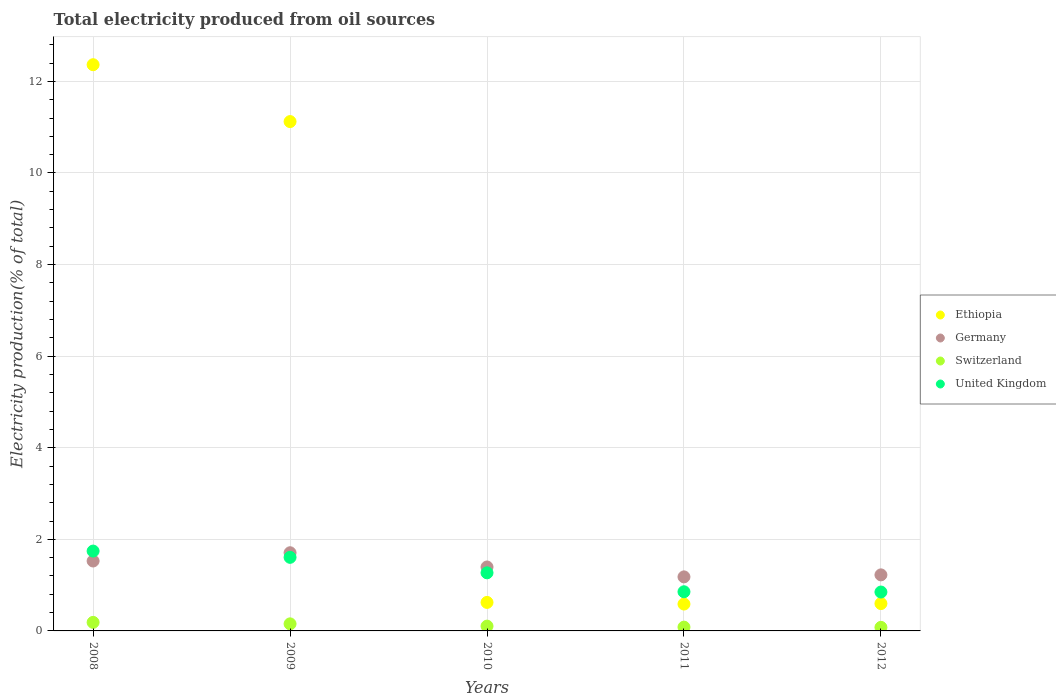Is the number of dotlines equal to the number of legend labels?
Your answer should be compact. Yes. What is the total electricity produced in United Kingdom in 2011?
Give a very brief answer. 0.86. Across all years, what is the maximum total electricity produced in Switzerland?
Your answer should be very brief. 0.19. Across all years, what is the minimum total electricity produced in United Kingdom?
Provide a succinct answer. 0.85. What is the total total electricity produced in Switzerland in the graph?
Make the answer very short. 0.61. What is the difference between the total electricity produced in Germany in 2009 and that in 2011?
Provide a succinct answer. 0.53. What is the difference between the total electricity produced in United Kingdom in 2011 and the total electricity produced in Ethiopia in 2010?
Provide a short and direct response. 0.23. What is the average total electricity produced in United Kingdom per year?
Keep it short and to the point. 1.26. In the year 2009, what is the difference between the total electricity produced in Germany and total electricity produced in Ethiopia?
Provide a short and direct response. -9.41. In how many years, is the total electricity produced in Switzerland greater than 11.2 %?
Provide a succinct answer. 0. What is the ratio of the total electricity produced in United Kingdom in 2009 to that in 2011?
Provide a short and direct response. 1.88. What is the difference between the highest and the second highest total electricity produced in Germany?
Ensure brevity in your answer.  0.18. What is the difference between the highest and the lowest total electricity produced in Ethiopia?
Your answer should be compact. 11.78. In how many years, is the total electricity produced in Ethiopia greater than the average total electricity produced in Ethiopia taken over all years?
Your response must be concise. 2. Is the sum of the total electricity produced in United Kingdom in 2008 and 2010 greater than the maximum total electricity produced in Switzerland across all years?
Ensure brevity in your answer.  Yes. Is it the case that in every year, the sum of the total electricity produced in Germany and total electricity produced in Ethiopia  is greater than the sum of total electricity produced in Switzerland and total electricity produced in United Kingdom?
Provide a short and direct response. No. Does the total electricity produced in Germany monotonically increase over the years?
Your answer should be compact. No. Is the total electricity produced in Germany strictly greater than the total electricity produced in Switzerland over the years?
Provide a succinct answer. Yes. Is the total electricity produced in Germany strictly less than the total electricity produced in Switzerland over the years?
Your answer should be compact. No. How many dotlines are there?
Provide a short and direct response. 4. What is the difference between two consecutive major ticks on the Y-axis?
Offer a terse response. 2. Are the values on the major ticks of Y-axis written in scientific E-notation?
Provide a short and direct response. No. Does the graph contain grids?
Provide a short and direct response. Yes. How many legend labels are there?
Offer a very short reply. 4. How are the legend labels stacked?
Provide a succinct answer. Vertical. What is the title of the graph?
Offer a very short reply. Total electricity produced from oil sources. What is the label or title of the X-axis?
Your response must be concise. Years. What is the label or title of the Y-axis?
Your response must be concise. Electricity production(% of total). What is the Electricity production(% of total) of Ethiopia in 2008?
Make the answer very short. 12.36. What is the Electricity production(% of total) in Germany in 2008?
Offer a terse response. 1.53. What is the Electricity production(% of total) in Switzerland in 2008?
Keep it short and to the point. 0.19. What is the Electricity production(% of total) in United Kingdom in 2008?
Give a very brief answer. 1.74. What is the Electricity production(% of total) in Ethiopia in 2009?
Ensure brevity in your answer.  11.12. What is the Electricity production(% of total) of Germany in 2009?
Provide a succinct answer. 1.71. What is the Electricity production(% of total) in Switzerland in 2009?
Ensure brevity in your answer.  0.15. What is the Electricity production(% of total) of United Kingdom in 2009?
Ensure brevity in your answer.  1.61. What is the Electricity production(% of total) in Ethiopia in 2010?
Keep it short and to the point. 0.62. What is the Electricity production(% of total) of Germany in 2010?
Offer a terse response. 1.4. What is the Electricity production(% of total) of Switzerland in 2010?
Make the answer very short. 0.1. What is the Electricity production(% of total) in United Kingdom in 2010?
Offer a very short reply. 1.27. What is the Electricity production(% of total) in Ethiopia in 2011?
Ensure brevity in your answer.  0.59. What is the Electricity production(% of total) of Germany in 2011?
Your response must be concise. 1.18. What is the Electricity production(% of total) of Switzerland in 2011?
Ensure brevity in your answer.  0.08. What is the Electricity production(% of total) in United Kingdom in 2011?
Make the answer very short. 0.86. What is the Electricity production(% of total) in Ethiopia in 2012?
Give a very brief answer. 0.6. What is the Electricity production(% of total) in Germany in 2012?
Provide a short and direct response. 1.22. What is the Electricity production(% of total) of Switzerland in 2012?
Ensure brevity in your answer.  0.08. What is the Electricity production(% of total) in United Kingdom in 2012?
Offer a very short reply. 0.85. Across all years, what is the maximum Electricity production(% of total) of Ethiopia?
Keep it short and to the point. 12.36. Across all years, what is the maximum Electricity production(% of total) in Germany?
Give a very brief answer. 1.71. Across all years, what is the maximum Electricity production(% of total) in Switzerland?
Your answer should be very brief. 0.19. Across all years, what is the maximum Electricity production(% of total) of United Kingdom?
Give a very brief answer. 1.74. Across all years, what is the minimum Electricity production(% of total) of Ethiopia?
Provide a succinct answer. 0.59. Across all years, what is the minimum Electricity production(% of total) in Germany?
Offer a terse response. 1.18. Across all years, what is the minimum Electricity production(% of total) in Switzerland?
Keep it short and to the point. 0.08. Across all years, what is the minimum Electricity production(% of total) in United Kingdom?
Provide a short and direct response. 0.85. What is the total Electricity production(% of total) in Ethiopia in the graph?
Give a very brief answer. 25.29. What is the total Electricity production(% of total) in Germany in the graph?
Keep it short and to the point. 7.03. What is the total Electricity production(% of total) in Switzerland in the graph?
Your answer should be compact. 0.61. What is the total Electricity production(% of total) of United Kingdom in the graph?
Provide a succinct answer. 6.32. What is the difference between the Electricity production(% of total) of Ethiopia in 2008 and that in 2009?
Offer a terse response. 1.24. What is the difference between the Electricity production(% of total) in Germany in 2008 and that in 2009?
Your response must be concise. -0.18. What is the difference between the Electricity production(% of total) in Switzerland in 2008 and that in 2009?
Give a very brief answer. 0.03. What is the difference between the Electricity production(% of total) in United Kingdom in 2008 and that in 2009?
Give a very brief answer. 0.14. What is the difference between the Electricity production(% of total) of Ethiopia in 2008 and that in 2010?
Your answer should be compact. 11.74. What is the difference between the Electricity production(% of total) in Germany in 2008 and that in 2010?
Give a very brief answer. 0.13. What is the difference between the Electricity production(% of total) in Switzerland in 2008 and that in 2010?
Give a very brief answer. 0.08. What is the difference between the Electricity production(% of total) in United Kingdom in 2008 and that in 2010?
Offer a terse response. 0.47. What is the difference between the Electricity production(% of total) of Ethiopia in 2008 and that in 2011?
Give a very brief answer. 11.78. What is the difference between the Electricity production(% of total) of Germany in 2008 and that in 2011?
Your response must be concise. 0.35. What is the difference between the Electricity production(% of total) in Switzerland in 2008 and that in 2011?
Give a very brief answer. 0.1. What is the difference between the Electricity production(% of total) of United Kingdom in 2008 and that in 2011?
Give a very brief answer. 0.89. What is the difference between the Electricity production(% of total) in Ethiopia in 2008 and that in 2012?
Your answer should be very brief. 11.77. What is the difference between the Electricity production(% of total) in Germany in 2008 and that in 2012?
Provide a short and direct response. 0.3. What is the difference between the Electricity production(% of total) of Switzerland in 2008 and that in 2012?
Keep it short and to the point. 0.11. What is the difference between the Electricity production(% of total) in United Kingdom in 2008 and that in 2012?
Provide a short and direct response. 0.89. What is the difference between the Electricity production(% of total) in Ethiopia in 2009 and that in 2010?
Your response must be concise. 10.5. What is the difference between the Electricity production(% of total) in Germany in 2009 and that in 2010?
Provide a succinct answer. 0.31. What is the difference between the Electricity production(% of total) in United Kingdom in 2009 and that in 2010?
Your response must be concise. 0.34. What is the difference between the Electricity production(% of total) in Ethiopia in 2009 and that in 2011?
Provide a short and direct response. 10.54. What is the difference between the Electricity production(% of total) of Germany in 2009 and that in 2011?
Offer a very short reply. 0.53. What is the difference between the Electricity production(% of total) of Switzerland in 2009 and that in 2011?
Offer a terse response. 0.07. What is the difference between the Electricity production(% of total) in United Kingdom in 2009 and that in 2011?
Make the answer very short. 0.75. What is the difference between the Electricity production(% of total) of Ethiopia in 2009 and that in 2012?
Offer a very short reply. 10.53. What is the difference between the Electricity production(% of total) in Germany in 2009 and that in 2012?
Provide a succinct answer. 0.48. What is the difference between the Electricity production(% of total) of Switzerland in 2009 and that in 2012?
Your answer should be compact. 0.08. What is the difference between the Electricity production(% of total) of United Kingdom in 2009 and that in 2012?
Give a very brief answer. 0.76. What is the difference between the Electricity production(% of total) in Ethiopia in 2010 and that in 2011?
Make the answer very short. 0.04. What is the difference between the Electricity production(% of total) of Germany in 2010 and that in 2011?
Ensure brevity in your answer.  0.22. What is the difference between the Electricity production(% of total) of Switzerland in 2010 and that in 2011?
Give a very brief answer. 0.02. What is the difference between the Electricity production(% of total) in United Kingdom in 2010 and that in 2011?
Make the answer very short. 0.41. What is the difference between the Electricity production(% of total) of Ethiopia in 2010 and that in 2012?
Make the answer very short. 0.03. What is the difference between the Electricity production(% of total) of Germany in 2010 and that in 2012?
Provide a short and direct response. 0.17. What is the difference between the Electricity production(% of total) in Switzerland in 2010 and that in 2012?
Give a very brief answer. 0.03. What is the difference between the Electricity production(% of total) in United Kingdom in 2010 and that in 2012?
Provide a short and direct response. 0.42. What is the difference between the Electricity production(% of total) in Ethiopia in 2011 and that in 2012?
Offer a very short reply. -0.01. What is the difference between the Electricity production(% of total) of Germany in 2011 and that in 2012?
Give a very brief answer. -0.04. What is the difference between the Electricity production(% of total) of Switzerland in 2011 and that in 2012?
Offer a very short reply. 0. What is the difference between the Electricity production(% of total) of United Kingdom in 2011 and that in 2012?
Keep it short and to the point. 0.01. What is the difference between the Electricity production(% of total) in Ethiopia in 2008 and the Electricity production(% of total) in Germany in 2009?
Keep it short and to the point. 10.66. What is the difference between the Electricity production(% of total) of Ethiopia in 2008 and the Electricity production(% of total) of Switzerland in 2009?
Your answer should be compact. 12.21. What is the difference between the Electricity production(% of total) in Ethiopia in 2008 and the Electricity production(% of total) in United Kingdom in 2009?
Give a very brief answer. 10.76. What is the difference between the Electricity production(% of total) in Germany in 2008 and the Electricity production(% of total) in Switzerland in 2009?
Provide a short and direct response. 1.37. What is the difference between the Electricity production(% of total) in Germany in 2008 and the Electricity production(% of total) in United Kingdom in 2009?
Provide a succinct answer. -0.08. What is the difference between the Electricity production(% of total) in Switzerland in 2008 and the Electricity production(% of total) in United Kingdom in 2009?
Ensure brevity in your answer.  -1.42. What is the difference between the Electricity production(% of total) of Ethiopia in 2008 and the Electricity production(% of total) of Germany in 2010?
Provide a succinct answer. 10.97. What is the difference between the Electricity production(% of total) in Ethiopia in 2008 and the Electricity production(% of total) in Switzerland in 2010?
Give a very brief answer. 12.26. What is the difference between the Electricity production(% of total) of Ethiopia in 2008 and the Electricity production(% of total) of United Kingdom in 2010?
Provide a short and direct response. 11.1. What is the difference between the Electricity production(% of total) in Germany in 2008 and the Electricity production(% of total) in Switzerland in 2010?
Keep it short and to the point. 1.42. What is the difference between the Electricity production(% of total) in Germany in 2008 and the Electricity production(% of total) in United Kingdom in 2010?
Your answer should be compact. 0.26. What is the difference between the Electricity production(% of total) of Switzerland in 2008 and the Electricity production(% of total) of United Kingdom in 2010?
Make the answer very short. -1.08. What is the difference between the Electricity production(% of total) in Ethiopia in 2008 and the Electricity production(% of total) in Germany in 2011?
Provide a succinct answer. 11.18. What is the difference between the Electricity production(% of total) in Ethiopia in 2008 and the Electricity production(% of total) in Switzerland in 2011?
Offer a terse response. 12.28. What is the difference between the Electricity production(% of total) of Ethiopia in 2008 and the Electricity production(% of total) of United Kingdom in 2011?
Your response must be concise. 11.51. What is the difference between the Electricity production(% of total) of Germany in 2008 and the Electricity production(% of total) of Switzerland in 2011?
Your response must be concise. 1.44. What is the difference between the Electricity production(% of total) in Germany in 2008 and the Electricity production(% of total) in United Kingdom in 2011?
Make the answer very short. 0.67. What is the difference between the Electricity production(% of total) in Switzerland in 2008 and the Electricity production(% of total) in United Kingdom in 2011?
Provide a succinct answer. -0.67. What is the difference between the Electricity production(% of total) in Ethiopia in 2008 and the Electricity production(% of total) in Germany in 2012?
Provide a succinct answer. 11.14. What is the difference between the Electricity production(% of total) in Ethiopia in 2008 and the Electricity production(% of total) in Switzerland in 2012?
Provide a succinct answer. 12.29. What is the difference between the Electricity production(% of total) in Ethiopia in 2008 and the Electricity production(% of total) in United Kingdom in 2012?
Ensure brevity in your answer.  11.52. What is the difference between the Electricity production(% of total) in Germany in 2008 and the Electricity production(% of total) in Switzerland in 2012?
Your answer should be very brief. 1.45. What is the difference between the Electricity production(% of total) in Germany in 2008 and the Electricity production(% of total) in United Kingdom in 2012?
Keep it short and to the point. 0.68. What is the difference between the Electricity production(% of total) in Switzerland in 2008 and the Electricity production(% of total) in United Kingdom in 2012?
Your response must be concise. -0.66. What is the difference between the Electricity production(% of total) of Ethiopia in 2009 and the Electricity production(% of total) of Germany in 2010?
Your response must be concise. 9.73. What is the difference between the Electricity production(% of total) in Ethiopia in 2009 and the Electricity production(% of total) in Switzerland in 2010?
Make the answer very short. 11.02. What is the difference between the Electricity production(% of total) in Ethiopia in 2009 and the Electricity production(% of total) in United Kingdom in 2010?
Make the answer very short. 9.85. What is the difference between the Electricity production(% of total) of Germany in 2009 and the Electricity production(% of total) of Switzerland in 2010?
Ensure brevity in your answer.  1.6. What is the difference between the Electricity production(% of total) in Germany in 2009 and the Electricity production(% of total) in United Kingdom in 2010?
Offer a very short reply. 0.44. What is the difference between the Electricity production(% of total) of Switzerland in 2009 and the Electricity production(% of total) of United Kingdom in 2010?
Ensure brevity in your answer.  -1.11. What is the difference between the Electricity production(% of total) of Ethiopia in 2009 and the Electricity production(% of total) of Germany in 2011?
Give a very brief answer. 9.94. What is the difference between the Electricity production(% of total) of Ethiopia in 2009 and the Electricity production(% of total) of Switzerland in 2011?
Your response must be concise. 11.04. What is the difference between the Electricity production(% of total) of Ethiopia in 2009 and the Electricity production(% of total) of United Kingdom in 2011?
Your answer should be compact. 10.27. What is the difference between the Electricity production(% of total) in Germany in 2009 and the Electricity production(% of total) in Switzerland in 2011?
Offer a very short reply. 1.62. What is the difference between the Electricity production(% of total) in Germany in 2009 and the Electricity production(% of total) in United Kingdom in 2011?
Keep it short and to the point. 0.85. What is the difference between the Electricity production(% of total) in Switzerland in 2009 and the Electricity production(% of total) in United Kingdom in 2011?
Your answer should be very brief. -0.7. What is the difference between the Electricity production(% of total) in Ethiopia in 2009 and the Electricity production(% of total) in Germany in 2012?
Offer a terse response. 9.9. What is the difference between the Electricity production(% of total) in Ethiopia in 2009 and the Electricity production(% of total) in Switzerland in 2012?
Keep it short and to the point. 11.04. What is the difference between the Electricity production(% of total) of Ethiopia in 2009 and the Electricity production(% of total) of United Kingdom in 2012?
Provide a short and direct response. 10.27. What is the difference between the Electricity production(% of total) in Germany in 2009 and the Electricity production(% of total) in Switzerland in 2012?
Offer a terse response. 1.63. What is the difference between the Electricity production(% of total) in Germany in 2009 and the Electricity production(% of total) in United Kingdom in 2012?
Your response must be concise. 0.86. What is the difference between the Electricity production(% of total) of Switzerland in 2009 and the Electricity production(% of total) of United Kingdom in 2012?
Your answer should be compact. -0.69. What is the difference between the Electricity production(% of total) in Ethiopia in 2010 and the Electricity production(% of total) in Germany in 2011?
Make the answer very short. -0.56. What is the difference between the Electricity production(% of total) of Ethiopia in 2010 and the Electricity production(% of total) of Switzerland in 2011?
Provide a short and direct response. 0.54. What is the difference between the Electricity production(% of total) in Ethiopia in 2010 and the Electricity production(% of total) in United Kingdom in 2011?
Offer a very short reply. -0.23. What is the difference between the Electricity production(% of total) in Germany in 2010 and the Electricity production(% of total) in Switzerland in 2011?
Provide a succinct answer. 1.31. What is the difference between the Electricity production(% of total) of Germany in 2010 and the Electricity production(% of total) of United Kingdom in 2011?
Keep it short and to the point. 0.54. What is the difference between the Electricity production(% of total) of Switzerland in 2010 and the Electricity production(% of total) of United Kingdom in 2011?
Ensure brevity in your answer.  -0.75. What is the difference between the Electricity production(% of total) of Ethiopia in 2010 and the Electricity production(% of total) of Germany in 2012?
Offer a very short reply. -0.6. What is the difference between the Electricity production(% of total) in Ethiopia in 2010 and the Electricity production(% of total) in Switzerland in 2012?
Offer a terse response. 0.54. What is the difference between the Electricity production(% of total) in Ethiopia in 2010 and the Electricity production(% of total) in United Kingdom in 2012?
Offer a very short reply. -0.23. What is the difference between the Electricity production(% of total) of Germany in 2010 and the Electricity production(% of total) of Switzerland in 2012?
Give a very brief answer. 1.32. What is the difference between the Electricity production(% of total) of Germany in 2010 and the Electricity production(% of total) of United Kingdom in 2012?
Keep it short and to the point. 0.55. What is the difference between the Electricity production(% of total) in Switzerland in 2010 and the Electricity production(% of total) in United Kingdom in 2012?
Your response must be concise. -0.74. What is the difference between the Electricity production(% of total) in Ethiopia in 2011 and the Electricity production(% of total) in Germany in 2012?
Your answer should be very brief. -0.64. What is the difference between the Electricity production(% of total) of Ethiopia in 2011 and the Electricity production(% of total) of Switzerland in 2012?
Keep it short and to the point. 0.51. What is the difference between the Electricity production(% of total) in Ethiopia in 2011 and the Electricity production(% of total) in United Kingdom in 2012?
Offer a terse response. -0.26. What is the difference between the Electricity production(% of total) in Germany in 2011 and the Electricity production(% of total) in Switzerland in 2012?
Offer a very short reply. 1.1. What is the difference between the Electricity production(% of total) of Germany in 2011 and the Electricity production(% of total) of United Kingdom in 2012?
Give a very brief answer. 0.33. What is the difference between the Electricity production(% of total) of Switzerland in 2011 and the Electricity production(% of total) of United Kingdom in 2012?
Offer a terse response. -0.77. What is the average Electricity production(% of total) of Ethiopia per year?
Provide a short and direct response. 5.06. What is the average Electricity production(% of total) in Germany per year?
Offer a terse response. 1.41. What is the average Electricity production(% of total) of Switzerland per year?
Ensure brevity in your answer.  0.12. What is the average Electricity production(% of total) of United Kingdom per year?
Offer a very short reply. 1.26. In the year 2008, what is the difference between the Electricity production(% of total) in Ethiopia and Electricity production(% of total) in Germany?
Offer a terse response. 10.84. In the year 2008, what is the difference between the Electricity production(% of total) in Ethiopia and Electricity production(% of total) in Switzerland?
Your answer should be compact. 12.18. In the year 2008, what is the difference between the Electricity production(% of total) in Ethiopia and Electricity production(% of total) in United Kingdom?
Ensure brevity in your answer.  10.62. In the year 2008, what is the difference between the Electricity production(% of total) in Germany and Electricity production(% of total) in Switzerland?
Ensure brevity in your answer.  1.34. In the year 2008, what is the difference between the Electricity production(% of total) of Germany and Electricity production(% of total) of United Kingdom?
Provide a short and direct response. -0.22. In the year 2008, what is the difference between the Electricity production(% of total) in Switzerland and Electricity production(% of total) in United Kingdom?
Keep it short and to the point. -1.56. In the year 2009, what is the difference between the Electricity production(% of total) in Ethiopia and Electricity production(% of total) in Germany?
Offer a terse response. 9.41. In the year 2009, what is the difference between the Electricity production(% of total) of Ethiopia and Electricity production(% of total) of Switzerland?
Make the answer very short. 10.97. In the year 2009, what is the difference between the Electricity production(% of total) of Ethiopia and Electricity production(% of total) of United Kingdom?
Ensure brevity in your answer.  9.52. In the year 2009, what is the difference between the Electricity production(% of total) in Germany and Electricity production(% of total) in Switzerland?
Ensure brevity in your answer.  1.55. In the year 2009, what is the difference between the Electricity production(% of total) of Germany and Electricity production(% of total) of United Kingdom?
Provide a succinct answer. 0.1. In the year 2009, what is the difference between the Electricity production(% of total) in Switzerland and Electricity production(% of total) in United Kingdom?
Your answer should be compact. -1.45. In the year 2010, what is the difference between the Electricity production(% of total) in Ethiopia and Electricity production(% of total) in Germany?
Your answer should be very brief. -0.77. In the year 2010, what is the difference between the Electricity production(% of total) of Ethiopia and Electricity production(% of total) of Switzerland?
Your answer should be very brief. 0.52. In the year 2010, what is the difference between the Electricity production(% of total) of Ethiopia and Electricity production(% of total) of United Kingdom?
Provide a short and direct response. -0.65. In the year 2010, what is the difference between the Electricity production(% of total) of Germany and Electricity production(% of total) of Switzerland?
Keep it short and to the point. 1.29. In the year 2010, what is the difference between the Electricity production(% of total) in Germany and Electricity production(% of total) in United Kingdom?
Provide a short and direct response. 0.13. In the year 2010, what is the difference between the Electricity production(% of total) of Switzerland and Electricity production(% of total) of United Kingdom?
Keep it short and to the point. -1.16. In the year 2011, what is the difference between the Electricity production(% of total) of Ethiopia and Electricity production(% of total) of Germany?
Make the answer very short. -0.59. In the year 2011, what is the difference between the Electricity production(% of total) in Ethiopia and Electricity production(% of total) in Switzerland?
Ensure brevity in your answer.  0.5. In the year 2011, what is the difference between the Electricity production(% of total) of Ethiopia and Electricity production(% of total) of United Kingdom?
Make the answer very short. -0.27. In the year 2011, what is the difference between the Electricity production(% of total) in Germany and Electricity production(% of total) in Switzerland?
Your response must be concise. 1.1. In the year 2011, what is the difference between the Electricity production(% of total) of Germany and Electricity production(% of total) of United Kingdom?
Your answer should be compact. 0.33. In the year 2011, what is the difference between the Electricity production(% of total) in Switzerland and Electricity production(% of total) in United Kingdom?
Your answer should be very brief. -0.77. In the year 2012, what is the difference between the Electricity production(% of total) in Ethiopia and Electricity production(% of total) in Germany?
Your answer should be compact. -0.63. In the year 2012, what is the difference between the Electricity production(% of total) of Ethiopia and Electricity production(% of total) of Switzerland?
Offer a very short reply. 0.52. In the year 2012, what is the difference between the Electricity production(% of total) in Ethiopia and Electricity production(% of total) in United Kingdom?
Provide a short and direct response. -0.25. In the year 2012, what is the difference between the Electricity production(% of total) of Germany and Electricity production(% of total) of Switzerland?
Provide a short and direct response. 1.15. In the year 2012, what is the difference between the Electricity production(% of total) in Germany and Electricity production(% of total) in United Kingdom?
Provide a short and direct response. 0.37. In the year 2012, what is the difference between the Electricity production(% of total) of Switzerland and Electricity production(% of total) of United Kingdom?
Provide a short and direct response. -0.77. What is the ratio of the Electricity production(% of total) of Ethiopia in 2008 to that in 2009?
Your response must be concise. 1.11. What is the ratio of the Electricity production(% of total) in Germany in 2008 to that in 2009?
Offer a terse response. 0.89. What is the ratio of the Electricity production(% of total) in Switzerland in 2008 to that in 2009?
Provide a succinct answer. 1.21. What is the ratio of the Electricity production(% of total) in United Kingdom in 2008 to that in 2009?
Your answer should be very brief. 1.09. What is the ratio of the Electricity production(% of total) of Ethiopia in 2008 to that in 2010?
Your response must be concise. 19.86. What is the ratio of the Electricity production(% of total) in Germany in 2008 to that in 2010?
Keep it short and to the point. 1.09. What is the ratio of the Electricity production(% of total) in Switzerland in 2008 to that in 2010?
Keep it short and to the point. 1.79. What is the ratio of the Electricity production(% of total) in United Kingdom in 2008 to that in 2010?
Ensure brevity in your answer.  1.37. What is the ratio of the Electricity production(% of total) of Ethiopia in 2008 to that in 2011?
Your answer should be very brief. 21.08. What is the ratio of the Electricity production(% of total) in Germany in 2008 to that in 2011?
Your answer should be compact. 1.29. What is the ratio of the Electricity production(% of total) in Switzerland in 2008 to that in 2011?
Your answer should be very brief. 2.25. What is the ratio of the Electricity production(% of total) of United Kingdom in 2008 to that in 2011?
Make the answer very short. 2.04. What is the ratio of the Electricity production(% of total) in Ethiopia in 2008 to that in 2012?
Give a very brief answer. 20.71. What is the ratio of the Electricity production(% of total) of Germany in 2008 to that in 2012?
Make the answer very short. 1.25. What is the ratio of the Electricity production(% of total) of Switzerland in 2008 to that in 2012?
Provide a succinct answer. 2.4. What is the ratio of the Electricity production(% of total) of United Kingdom in 2008 to that in 2012?
Your answer should be compact. 2.05. What is the ratio of the Electricity production(% of total) of Ethiopia in 2009 to that in 2010?
Your response must be concise. 17.87. What is the ratio of the Electricity production(% of total) of Germany in 2009 to that in 2010?
Give a very brief answer. 1.22. What is the ratio of the Electricity production(% of total) of Switzerland in 2009 to that in 2010?
Provide a short and direct response. 1.48. What is the ratio of the Electricity production(% of total) of United Kingdom in 2009 to that in 2010?
Make the answer very short. 1.27. What is the ratio of the Electricity production(% of total) in Ethiopia in 2009 to that in 2011?
Offer a terse response. 18.96. What is the ratio of the Electricity production(% of total) of Germany in 2009 to that in 2011?
Ensure brevity in your answer.  1.45. What is the ratio of the Electricity production(% of total) in Switzerland in 2009 to that in 2011?
Make the answer very short. 1.87. What is the ratio of the Electricity production(% of total) in United Kingdom in 2009 to that in 2011?
Your response must be concise. 1.88. What is the ratio of the Electricity production(% of total) in Ethiopia in 2009 to that in 2012?
Your answer should be compact. 18.63. What is the ratio of the Electricity production(% of total) in Germany in 2009 to that in 2012?
Give a very brief answer. 1.4. What is the ratio of the Electricity production(% of total) of Switzerland in 2009 to that in 2012?
Keep it short and to the point. 1.99. What is the ratio of the Electricity production(% of total) in United Kingdom in 2009 to that in 2012?
Make the answer very short. 1.89. What is the ratio of the Electricity production(% of total) in Ethiopia in 2010 to that in 2011?
Provide a short and direct response. 1.06. What is the ratio of the Electricity production(% of total) of Germany in 2010 to that in 2011?
Ensure brevity in your answer.  1.18. What is the ratio of the Electricity production(% of total) of Switzerland in 2010 to that in 2011?
Ensure brevity in your answer.  1.26. What is the ratio of the Electricity production(% of total) of United Kingdom in 2010 to that in 2011?
Offer a terse response. 1.48. What is the ratio of the Electricity production(% of total) in Ethiopia in 2010 to that in 2012?
Give a very brief answer. 1.04. What is the ratio of the Electricity production(% of total) of Germany in 2010 to that in 2012?
Provide a succinct answer. 1.14. What is the ratio of the Electricity production(% of total) in Switzerland in 2010 to that in 2012?
Give a very brief answer. 1.34. What is the ratio of the Electricity production(% of total) in United Kingdom in 2010 to that in 2012?
Offer a terse response. 1.49. What is the ratio of the Electricity production(% of total) in Ethiopia in 2011 to that in 2012?
Your answer should be very brief. 0.98. What is the ratio of the Electricity production(% of total) in Switzerland in 2011 to that in 2012?
Offer a terse response. 1.06. What is the difference between the highest and the second highest Electricity production(% of total) of Ethiopia?
Give a very brief answer. 1.24. What is the difference between the highest and the second highest Electricity production(% of total) in Germany?
Ensure brevity in your answer.  0.18. What is the difference between the highest and the second highest Electricity production(% of total) of Switzerland?
Ensure brevity in your answer.  0.03. What is the difference between the highest and the second highest Electricity production(% of total) of United Kingdom?
Your response must be concise. 0.14. What is the difference between the highest and the lowest Electricity production(% of total) in Ethiopia?
Give a very brief answer. 11.78. What is the difference between the highest and the lowest Electricity production(% of total) of Germany?
Your answer should be very brief. 0.53. What is the difference between the highest and the lowest Electricity production(% of total) of Switzerland?
Keep it short and to the point. 0.11. What is the difference between the highest and the lowest Electricity production(% of total) of United Kingdom?
Provide a succinct answer. 0.89. 